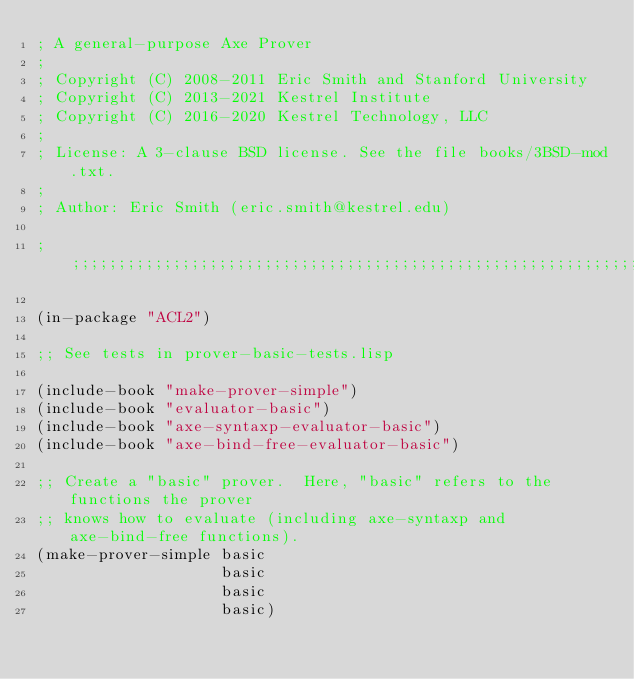Convert code to text. <code><loc_0><loc_0><loc_500><loc_500><_Lisp_>; A general-purpose Axe Prover
;
; Copyright (C) 2008-2011 Eric Smith and Stanford University
; Copyright (C) 2013-2021 Kestrel Institute
; Copyright (C) 2016-2020 Kestrel Technology, LLC
;
; License: A 3-clause BSD license. See the file books/3BSD-mod.txt.
;
; Author: Eric Smith (eric.smith@kestrel.edu)

;;;;;;;;;;;;;;;;;;;;;;;;;;;;;;;;;;;;;;;;;;;;;;;;;;;;;;;;;;;;;;;;;;;;;;;;;;;;;;;;

(in-package "ACL2")

;; See tests in prover-basic-tests.lisp

(include-book "make-prover-simple")
(include-book "evaluator-basic")
(include-book "axe-syntaxp-evaluator-basic")
(include-book "axe-bind-free-evaluator-basic")

;; Create a "basic" prover.  Here, "basic" refers to the functions the prover
;; knows how to evaluate (including axe-syntaxp and axe-bind-free functions).
(make-prover-simple basic
                    basic
                    basic
                    basic)
</code> 